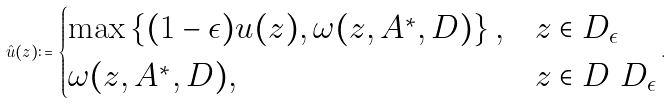<formula> <loc_0><loc_0><loc_500><loc_500>\hat { u } ( z ) \colon = \begin{cases} \max \left \{ ( 1 - \epsilon ) u ( z ) , \omega ( z , A ^ { \ast } , D ) \right \} , & z \in D _ { \epsilon } \\ \omega ( z , A ^ { \ast } , D ) , & z \in D \ D _ { \epsilon } \end{cases} .</formula> 